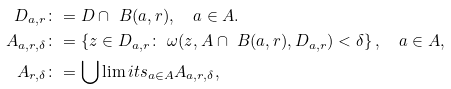Convert formula to latex. <formula><loc_0><loc_0><loc_500><loc_500>D _ { a , r } & \colon = D \cap \ B ( a , r ) , \quad a \in A . \\ A _ { a , r , \delta } & \colon = \left \{ z \in D _ { a , r } \colon \ \omega ( z , A \cap \ B ( a , r ) , D _ { a , r } ) < \delta \right \} , \quad a \in A , \\ A _ { r , \delta } & \colon = \bigcup \lim i t s _ { a \in A } A _ { a , r , \delta } ,</formula> 